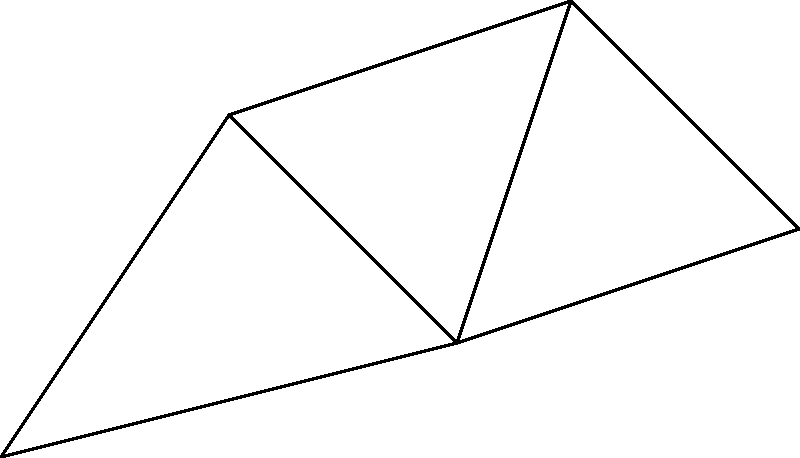At a corporate event, you need to determine the shortest path for catering staff to navigate between multiple event stations (S1 to S5) while visiting all stations. The distances between stations are shown in the diagram. What is the minimum total distance the staff needs to travel to visit all stations, starting from S1 and ending at S5? To solve this problem, we need to find the shortest path that visits all vertices in the graph, starting at S1 and ending at S5. This is a variation of the Traveling Salesman Problem.

Let's consider all possible paths:

1. S1 -> S2 -> S3 -> S4 -> S5
   Distance: 5 + 4 + 3 + 4 = 16

2. S1 -> S2 -> S4 -> S3 -> S5
   Distance: 5 + 5 + 3 + 3 = 16

3. S1 -> S3 -> S2 -> S4 -> S5
   Distance: 6 + 4 + 5 + 4 = 19

4. S1 -> S3 -> S4 -> S2 -> S5
   Distance: 6 + 3 + 5 + (no direct path, invalid)

5. S1 -> S3 -> S5 -> S4 -> S2
   Distance: 6 + 3 + 4 + (no direct path, invalid)

The shortest valid path is either option 1 or 2, both with a total distance of 16.

Therefore, the minimum total distance the catering staff needs to travel is 16 units.
Answer: 16 units 